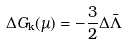Convert formula to latex. <formula><loc_0><loc_0><loc_500><loc_500>\Delta G _ { \text {k} } ( \mu ) = - \frac { 3 } { 2 } \Delta \bar { \Lambda }</formula> 